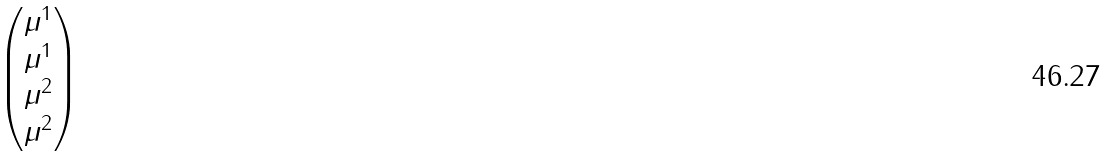Convert formula to latex. <formula><loc_0><loc_0><loc_500><loc_500>\begin{pmatrix} \mu ^ { 1 } \\ \mu ^ { 1 } \\ \mu ^ { 2 } \\ \mu ^ { 2 } \end{pmatrix}</formula> 